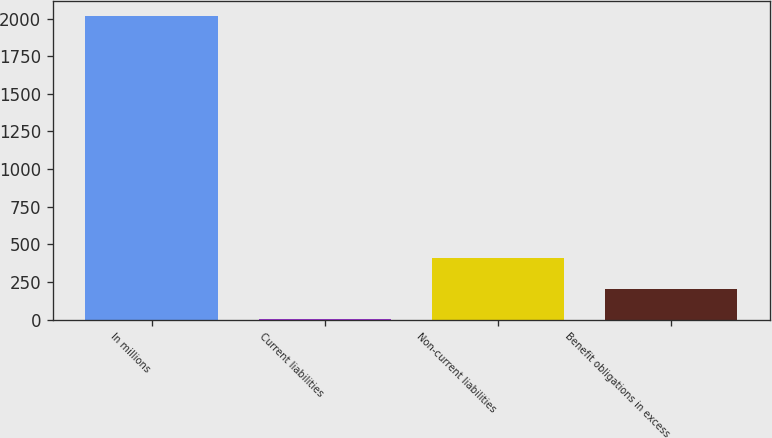<chart> <loc_0><loc_0><loc_500><loc_500><bar_chart><fcel>In millions<fcel>Current liabilities<fcel>Non-current liabilities<fcel>Benefit obligations in excess<nl><fcel>2014<fcel>4.7<fcel>406.56<fcel>205.63<nl></chart> 